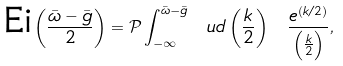Convert formula to latex. <formula><loc_0><loc_0><loc_500><loc_500>\text {Ei} \left ( \frac { \bar { \omega } - \bar { g } } { 2 } \right ) = \mathcal { P } \int ^ { \bar { \omega } - \bar { g } } _ { - \infty } \ u d \left ( \frac { k } { 2 } \right ) \ \frac { e ^ { ( k / 2 ) } } { \left ( \frac { k } { 2 } \right ) } ,</formula> 